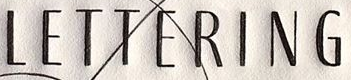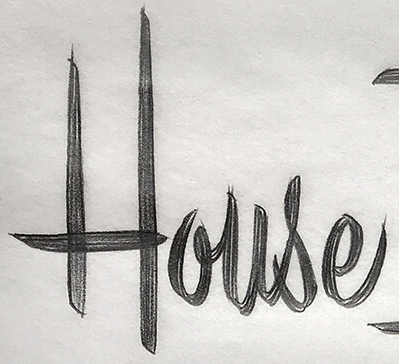Identify the words shown in these images in order, separated by a semicolon. LETTERING; House 